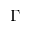<formula> <loc_0><loc_0><loc_500><loc_500>\Gamma</formula> 